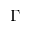<formula> <loc_0><loc_0><loc_500><loc_500>\Gamma</formula> 